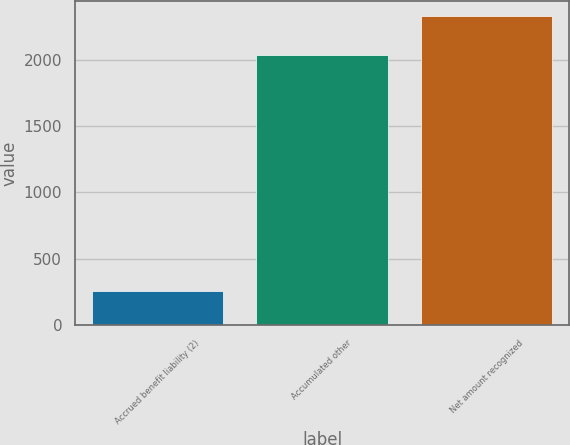<chart> <loc_0><loc_0><loc_500><loc_500><bar_chart><fcel>Accrued benefit liability (2)<fcel>Accumulated other<fcel>Net amount recognized<nl><fcel>257<fcel>2036<fcel>2328<nl></chart> 